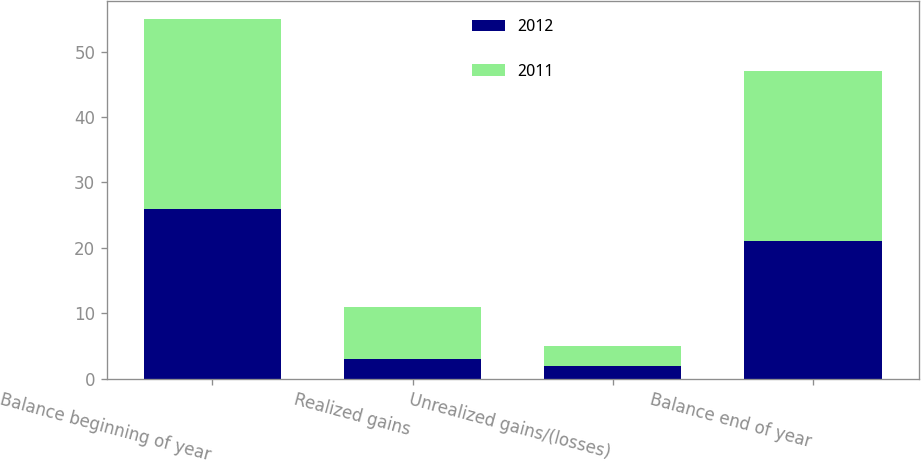Convert chart to OTSL. <chart><loc_0><loc_0><loc_500><loc_500><stacked_bar_chart><ecel><fcel>Balance beginning of year<fcel>Realized gains<fcel>Unrealized gains/(losses)<fcel>Balance end of year<nl><fcel>2012<fcel>26<fcel>3<fcel>2<fcel>21<nl><fcel>2011<fcel>29<fcel>8<fcel>3<fcel>26<nl></chart> 